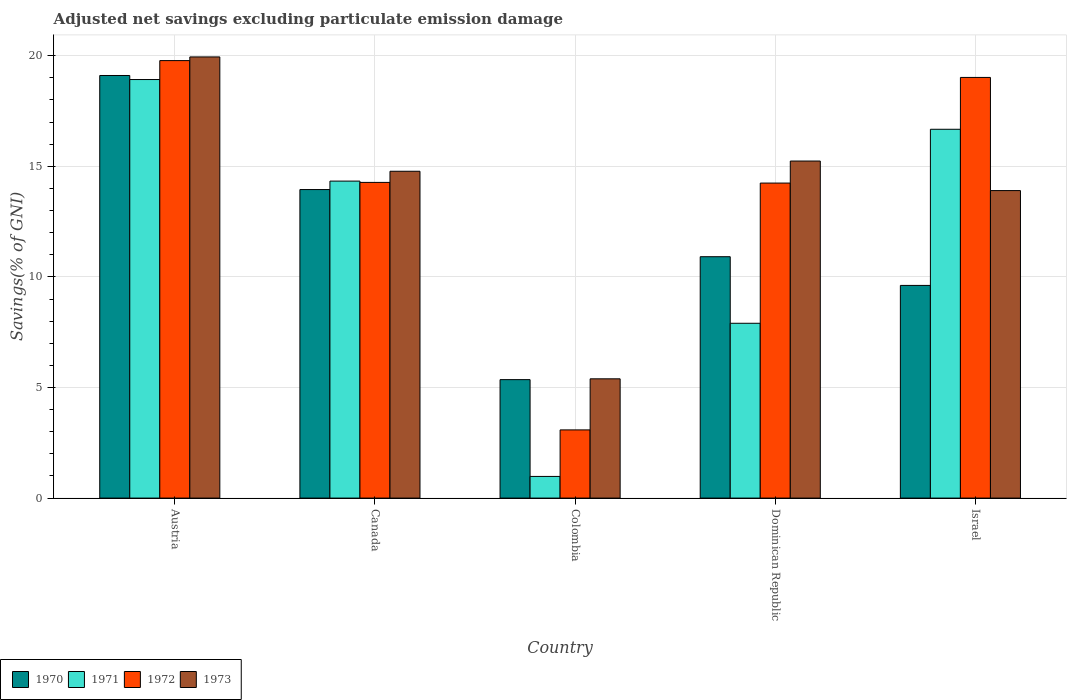How many different coloured bars are there?
Provide a succinct answer. 4. Are the number of bars per tick equal to the number of legend labels?
Provide a short and direct response. Yes. Are the number of bars on each tick of the X-axis equal?
Keep it short and to the point. Yes. How many bars are there on the 2nd tick from the left?
Your answer should be very brief. 4. How many bars are there on the 5th tick from the right?
Make the answer very short. 4. In how many cases, is the number of bars for a given country not equal to the number of legend labels?
Make the answer very short. 0. What is the adjusted net savings in 1973 in Israel?
Your answer should be compact. 13.9. Across all countries, what is the maximum adjusted net savings in 1971?
Your answer should be compact. 18.92. Across all countries, what is the minimum adjusted net savings in 1972?
Provide a succinct answer. 3.08. In which country was the adjusted net savings in 1972 maximum?
Give a very brief answer. Austria. What is the total adjusted net savings in 1972 in the graph?
Offer a very short reply. 70.39. What is the difference between the adjusted net savings in 1973 in Austria and that in Israel?
Your response must be concise. 6.04. What is the difference between the adjusted net savings in 1971 in Dominican Republic and the adjusted net savings in 1973 in Austria?
Provide a succinct answer. -12.04. What is the average adjusted net savings in 1973 per country?
Ensure brevity in your answer.  13.85. What is the difference between the adjusted net savings of/in 1972 and adjusted net savings of/in 1973 in Dominican Republic?
Ensure brevity in your answer.  -1. In how many countries, is the adjusted net savings in 1972 greater than 17 %?
Provide a succinct answer. 2. What is the ratio of the adjusted net savings in 1971 in Colombia to that in Israel?
Provide a succinct answer. 0.06. What is the difference between the highest and the second highest adjusted net savings in 1973?
Give a very brief answer. 5.17. What is the difference between the highest and the lowest adjusted net savings in 1970?
Offer a very short reply. 13.75. Is the sum of the adjusted net savings in 1972 in Canada and Israel greater than the maximum adjusted net savings in 1970 across all countries?
Keep it short and to the point. Yes. Is it the case that in every country, the sum of the adjusted net savings in 1970 and adjusted net savings in 1973 is greater than the sum of adjusted net savings in 1972 and adjusted net savings in 1971?
Offer a terse response. No. Is it the case that in every country, the sum of the adjusted net savings in 1973 and adjusted net savings in 1970 is greater than the adjusted net savings in 1971?
Offer a very short reply. Yes. Are the values on the major ticks of Y-axis written in scientific E-notation?
Provide a succinct answer. No. Does the graph contain any zero values?
Keep it short and to the point. No. Does the graph contain grids?
Offer a very short reply. Yes. Where does the legend appear in the graph?
Provide a succinct answer. Bottom left. What is the title of the graph?
Ensure brevity in your answer.  Adjusted net savings excluding particulate emission damage. Does "2007" appear as one of the legend labels in the graph?
Offer a terse response. No. What is the label or title of the Y-axis?
Ensure brevity in your answer.  Savings(% of GNI). What is the Savings(% of GNI) in 1970 in Austria?
Provide a short and direct response. 19.11. What is the Savings(% of GNI) in 1971 in Austria?
Your answer should be very brief. 18.92. What is the Savings(% of GNI) in 1972 in Austria?
Offer a terse response. 19.78. What is the Savings(% of GNI) in 1973 in Austria?
Keep it short and to the point. 19.94. What is the Savings(% of GNI) of 1970 in Canada?
Give a very brief answer. 13.95. What is the Savings(% of GNI) of 1971 in Canada?
Provide a succinct answer. 14.33. What is the Savings(% of GNI) of 1972 in Canada?
Give a very brief answer. 14.27. What is the Savings(% of GNI) in 1973 in Canada?
Ensure brevity in your answer.  14.78. What is the Savings(% of GNI) of 1970 in Colombia?
Your response must be concise. 5.36. What is the Savings(% of GNI) of 1971 in Colombia?
Ensure brevity in your answer.  0.98. What is the Savings(% of GNI) of 1972 in Colombia?
Your response must be concise. 3.08. What is the Savings(% of GNI) of 1973 in Colombia?
Keep it short and to the point. 5.39. What is the Savings(% of GNI) of 1970 in Dominican Republic?
Your response must be concise. 10.91. What is the Savings(% of GNI) in 1971 in Dominican Republic?
Provide a succinct answer. 7.9. What is the Savings(% of GNI) of 1972 in Dominican Republic?
Offer a very short reply. 14.24. What is the Savings(% of GNI) in 1973 in Dominican Republic?
Make the answer very short. 15.24. What is the Savings(% of GNI) of 1970 in Israel?
Your response must be concise. 9.61. What is the Savings(% of GNI) of 1971 in Israel?
Keep it short and to the point. 16.67. What is the Savings(% of GNI) in 1972 in Israel?
Your answer should be very brief. 19.02. What is the Savings(% of GNI) of 1973 in Israel?
Your answer should be compact. 13.9. Across all countries, what is the maximum Savings(% of GNI) in 1970?
Ensure brevity in your answer.  19.11. Across all countries, what is the maximum Savings(% of GNI) in 1971?
Offer a very short reply. 18.92. Across all countries, what is the maximum Savings(% of GNI) in 1972?
Keep it short and to the point. 19.78. Across all countries, what is the maximum Savings(% of GNI) of 1973?
Give a very brief answer. 19.94. Across all countries, what is the minimum Savings(% of GNI) of 1970?
Offer a very short reply. 5.36. Across all countries, what is the minimum Savings(% of GNI) in 1971?
Give a very brief answer. 0.98. Across all countries, what is the minimum Savings(% of GNI) in 1972?
Offer a terse response. 3.08. Across all countries, what is the minimum Savings(% of GNI) in 1973?
Ensure brevity in your answer.  5.39. What is the total Savings(% of GNI) of 1970 in the graph?
Your answer should be compact. 58.94. What is the total Savings(% of GNI) of 1971 in the graph?
Offer a very short reply. 58.81. What is the total Savings(% of GNI) in 1972 in the graph?
Provide a short and direct response. 70.39. What is the total Savings(% of GNI) in 1973 in the graph?
Make the answer very short. 69.25. What is the difference between the Savings(% of GNI) of 1970 in Austria and that in Canada?
Ensure brevity in your answer.  5.16. What is the difference between the Savings(% of GNI) of 1971 in Austria and that in Canada?
Provide a succinct answer. 4.59. What is the difference between the Savings(% of GNI) of 1972 in Austria and that in Canada?
Offer a very short reply. 5.51. What is the difference between the Savings(% of GNI) of 1973 in Austria and that in Canada?
Give a very brief answer. 5.17. What is the difference between the Savings(% of GNI) of 1970 in Austria and that in Colombia?
Provide a short and direct response. 13.75. What is the difference between the Savings(% of GNI) of 1971 in Austria and that in Colombia?
Offer a very short reply. 17.94. What is the difference between the Savings(% of GNI) in 1972 in Austria and that in Colombia?
Give a very brief answer. 16.7. What is the difference between the Savings(% of GNI) of 1973 in Austria and that in Colombia?
Offer a terse response. 14.55. What is the difference between the Savings(% of GNI) of 1970 in Austria and that in Dominican Republic?
Provide a short and direct response. 8.19. What is the difference between the Savings(% of GNI) in 1971 in Austria and that in Dominican Republic?
Your response must be concise. 11.02. What is the difference between the Savings(% of GNI) of 1972 in Austria and that in Dominican Republic?
Your response must be concise. 5.54. What is the difference between the Savings(% of GNI) of 1973 in Austria and that in Dominican Republic?
Offer a terse response. 4.71. What is the difference between the Savings(% of GNI) of 1970 in Austria and that in Israel?
Offer a very short reply. 9.49. What is the difference between the Savings(% of GNI) of 1971 in Austria and that in Israel?
Provide a short and direct response. 2.25. What is the difference between the Savings(% of GNI) in 1972 in Austria and that in Israel?
Provide a succinct answer. 0.76. What is the difference between the Savings(% of GNI) of 1973 in Austria and that in Israel?
Offer a very short reply. 6.04. What is the difference between the Savings(% of GNI) of 1970 in Canada and that in Colombia?
Offer a very short reply. 8.59. What is the difference between the Savings(% of GNI) of 1971 in Canada and that in Colombia?
Ensure brevity in your answer.  13.35. What is the difference between the Savings(% of GNI) of 1972 in Canada and that in Colombia?
Your response must be concise. 11.19. What is the difference between the Savings(% of GNI) in 1973 in Canada and that in Colombia?
Offer a very short reply. 9.38. What is the difference between the Savings(% of GNI) of 1970 in Canada and that in Dominican Republic?
Make the answer very short. 3.04. What is the difference between the Savings(% of GNI) of 1971 in Canada and that in Dominican Republic?
Ensure brevity in your answer.  6.43. What is the difference between the Savings(% of GNI) of 1972 in Canada and that in Dominican Republic?
Your response must be concise. 0.03. What is the difference between the Savings(% of GNI) of 1973 in Canada and that in Dominican Republic?
Offer a very short reply. -0.46. What is the difference between the Savings(% of GNI) in 1970 in Canada and that in Israel?
Ensure brevity in your answer.  4.33. What is the difference between the Savings(% of GNI) of 1971 in Canada and that in Israel?
Make the answer very short. -2.34. What is the difference between the Savings(% of GNI) of 1972 in Canada and that in Israel?
Make the answer very short. -4.75. What is the difference between the Savings(% of GNI) of 1973 in Canada and that in Israel?
Your answer should be compact. 0.87. What is the difference between the Savings(% of GNI) in 1970 in Colombia and that in Dominican Republic?
Make the answer very short. -5.56. What is the difference between the Savings(% of GNI) of 1971 in Colombia and that in Dominican Republic?
Offer a very short reply. -6.92. What is the difference between the Savings(% of GNI) in 1972 in Colombia and that in Dominican Republic?
Your answer should be compact. -11.16. What is the difference between the Savings(% of GNI) in 1973 in Colombia and that in Dominican Republic?
Offer a very short reply. -9.85. What is the difference between the Savings(% of GNI) of 1970 in Colombia and that in Israel?
Offer a terse response. -4.26. What is the difference between the Savings(% of GNI) in 1971 in Colombia and that in Israel?
Give a very brief answer. -15.7. What is the difference between the Savings(% of GNI) in 1972 in Colombia and that in Israel?
Keep it short and to the point. -15.94. What is the difference between the Savings(% of GNI) of 1973 in Colombia and that in Israel?
Your answer should be compact. -8.51. What is the difference between the Savings(% of GNI) in 1970 in Dominican Republic and that in Israel?
Provide a succinct answer. 1.3. What is the difference between the Savings(% of GNI) of 1971 in Dominican Republic and that in Israel?
Ensure brevity in your answer.  -8.77. What is the difference between the Savings(% of GNI) of 1972 in Dominican Republic and that in Israel?
Give a very brief answer. -4.78. What is the difference between the Savings(% of GNI) in 1973 in Dominican Republic and that in Israel?
Offer a very short reply. 1.34. What is the difference between the Savings(% of GNI) in 1970 in Austria and the Savings(% of GNI) in 1971 in Canada?
Keep it short and to the point. 4.77. What is the difference between the Savings(% of GNI) in 1970 in Austria and the Savings(% of GNI) in 1972 in Canada?
Your answer should be very brief. 4.83. What is the difference between the Savings(% of GNI) of 1970 in Austria and the Savings(% of GNI) of 1973 in Canada?
Your response must be concise. 4.33. What is the difference between the Savings(% of GNI) of 1971 in Austria and the Savings(% of GNI) of 1972 in Canada?
Offer a very short reply. 4.65. What is the difference between the Savings(% of GNI) of 1971 in Austria and the Savings(% of GNI) of 1973 in Canada?
Make the answer very short. 4.15. What is the difference between the Savings(% of GNI) in 1972 in Austria and the Savings(% of GNI) in 1973 in Canada?
Your answer should be compact. 5. What is the difference between the Savings(% of GNI) of 1970 in Austria and the Savings(% of GNI) of 1971 in Colombia?
Your answer should be very brief. 18.13. What is the difference between the Savings(% of GNI) of 1970 in Austria and the Savings(% of GNI) of 1972 in Colombia?
Provide a short and direct response. 16.02. What is the difference between the Savings(% of GNI) of 1970 in Austria and the Savings(% of GNI) of 1973 in Colombia?
Give a very brief answer. 13.71. What is the difference between the Savings(% of GNI) of 1971 in Austria and the Savings(% of GNI) of 1972 in Colombia?
Your answer should be compact. 15.84. What is the difference between the Savings(% of GNI) of 1971 in Austria and the Savings(% of GNI) of 1973 in Colombia?
Your answer should be very brief. 13.53. What is the difference between the Savings(% of GNI) of 1972 in Austria and the Savings(% of GNI) of 1973 in Colombia?
Your answer should be very brief. 14.39. What is the difference between the Savings(% of GNI) of 1970 in Austria and the Savings(% of GNI) of 1971 in Dominican Republic?
Provide a short and direct response. 11.2. What is the difference between the Savings(% of GNI) in 1970 in Austria and the Savings(% of GNI) in 1972 in Dominican Republic?
Make the answer very short. 4.86. What is the difference between the Savings(% of GNI) of 1970 in Austria and the Savings(% of GNI) of 1973 in Dominican Republic?
Offer a very short reply. 3.87. What is the difference between the Savings(% of GNI) in 1971 in Austria and the Savings(% of GNI) in 1972 in Dominican Republic?
Your response must be concise. 4.68. What is the difference between the Savings(% of GNI) in 1971 in Austria and the Savings(% of GNI) in 1973 in Dominican Republic?
Your answer should be very brief. 3.68. What is the difference between the Savings(% of GNI) in 1972 in Austria and the Savings(% of GNI) in 1973 in Dominican Republic?
Provide a succinct answer. 4.54. What is the difference between the Savings(% of GNI) in 1970 in Austria and the Savings(% of GNI) in 1971 in Israel?
Your response must be concise. 2.43. What is the difference between the Savings(% of GNI) in 1970 in Austria and the Savings(% of GNI) in 1972 in Israel?
Provide a succinct answer. 0.09. What is the difference between the Savings(% of GNI) in 1970 in Austria and the Savings(% of GNI) in 1973 in Israel?
Your answer should be very brief. 5.2. What is the difference between the Savings(% of GNI) in 1971 in Austria and the Savings(% of GNI) in 1972 in Israel?
Give a very brief answer. -0.1. What is the difference between the Savings(% of GNI) of 1971 in Austria and the Savings(% of GNI) of 1973 in Israel?
Your answer should be compact. 5.02. What is the difference between the Savings(% of GNI) in 1972 in Austria and the Savings(% of GNI) in 1973 in Israel?
Give a very brief answer. 5.88. What is the difference between the Savings(% of GNI) of 1970 in Canada and the Savings(% of GNI) of 1971 in Colombia?
Offer a very short reply. 12.97. What is the difference between the Savings(% of GNI) of 1970 in Canada and the Savings(% of GNI) of 1972 in Colombia?
Your answer should be very brief. 10.87. What is the difference between the Savings(% of GNI) in 1970 in Canada and the Savings(% of GNI) in 1973 in Colombia?
Provide a short and direct response. 8.56. What is the difference between the Savings(% of GNI) in 1971 in Canada and the Savings(% of GNI) in 1972 in Colombia?
Make the answer very short. 11.25. What is the difference between the Savings(% of GNI) in 1971 in Canada and the Savings(% of GNI) in 1973 in Colombia?
Your response must be concise. 8.94. What is the difference between the Savings(% of GNI) of 1972 in Canada and the Savings(% of GNI) of 1973 in Colombia?
Your response must be concise. 8.88. What is the difference between the Savings(% of GNI) of 1970 in Canada and the Savings(% of GNI) of 1971 in Dominican Republic?
Provide a short and direct response. 6.05. What is the difference between the Savings(% of GNI) in 1970 in Canada and the Savings(% of GNI) in 1972 in Dominican Republic?
Your response must be concise. -0.29. What is the difference between the Savings(% of GNI) in 1970 in Canada and the Savings(% of GNI) in 1973 in Dominican Republic?
Provide a succinct answer. -1.29. What is the difference between the Savings(% of GNI) of 1971 in Canada and the Savings(% of GNI) of 1972 in Dominican Republic?
Make the answer very short. 0.09. What is the difference between the Savings(% of GNI) of 1971 in Canada and the Savings(% of GNI) of 1973 in Dominican Republic?
Your answer should be compact. -0.91. What is the difference between the Savings(% of GNI) in 1972 in Canada and the Savings(% of GNI) in 1973 in Dominican Republic?
Provide a short and direct response. -0.97. What is the difference between the Savings(% of GNI) of 1970 in Canada and the Savings(% of GNI) of 1971 in Israel?
Offer a very short reply. -2.73. What is the difference between the Savings(% of GNI) of 1970 in Canada and the Savings(% of GNI) of 1972 in Israel?
Provide a short and direct response. -5.07. What is the difference between the Savings(% of GNI) in 1970 in Canada and the Savings(% of GNI) in 1973 in Israel?
Ensure brevity in your answer.  0.05. What is the difference between the Savings(% of GNI) in 1971 in Canada and the Savings(% of GNI) in 1972 in Israel?
Offer a terse response. -4.69. What is the difference between the Savings(% of GNI) of 1971 in Canada and the Savings(% of GNI) of 1973 in Israel?
Your answer should be compact. 0.43. What is the difference between the Savings(% of GNI) in 1972 in Canada and the Savings(% of GNI) in 1973 in Israel?
Your response must be concise. 0.37. What is the difference between the Savings(% of GNI) of 1970 in Colombia and the Savings(% of GNI) of 1971 in Dominican Republic?
Provide a short and direct response. -2.55. What is the difference between the Savings(% of GNI) in 1970 in Colombia and the Savings(% of GNI) in 1972 in Dominican Republic?
Your response must be concise. -8.89. What is the difference between the Savings(% of GNI) of 1970 in Colombia and the Savings(% of GNI) of 1973 in Dominican Republic?
Offer a terse response. -9.88. What is the difference between the Savings(% of GNI) of 1971 in Colombia and the Savings(% of GNI) of 1972 in Dominican Republic?
Provide a succinct answer. -13.26. What is the difference between the Savings(% of GNI) in 1971 in Colombia and the Savings(% of GNI) in 1973 in Dominican Republic?
Your answer should be compact. -14.26. What is the difference between the Savings(% of GNI) in 1972 in Colombia and the Savings(% of GNI) in 1973 in Dominican Republic?
Your answer should be compact. -12.15. What is the difference between the Savings(% of GNI) in 1970 in Colombia and the Savings(% of GNI) in 1971 in Israel?
Provide a succinct answer. -11.32. What is the difference between the Savings(% of GNI) of 1970 in Colombia and the Savings(% of GNI) of 1972 in Israel?
Provide a short and direct response. -13.66. What is the difference between the Savings(% of GNI) of 1970 in Colombia and the Savings(% of GNI) of 1973 in Israel?
Your response must be concise. -8.55. What is the difference between the Savings(% of GNI) of 1971 in Colombia and the Savings(% of GNI) of 1972 in Israel?
Provide a succinct answer. -18.04. What is the difference between the Savings(% of GNI) in 1971 in Colombia and the Savings(% of GNI) in 1973 in Israel?
Give a very brief answer. -12.92. What is the difference between the Savings(% of GNI) in 1972 in Colombia and the Savings(% of GNI) in 1973 in Israel?
Offer a terse response. -10.82. What is the difference between the Savings(% of GNI) in 1970 in Dominican Republic and the Savings(% of GNI) in 1971 in Israel?
Give a very brief answer. -5.76. What is the difference between the Savings(% of GNI) in 1970 in Dominican Republic and the Savings(% of GNI) in 1972 in Israel?
Give a very brief answer. -8.11. What is the difference between the Savings(% of GNI) in 1970 in Dominican Republic and the Savings(% of GNI) in 1973 in Israel?
Your answer should be very brief. -2.99. What is the difference between the Savings(% of GNI) of 1971 in Dominican Republic and the Savings(% of GNI) of 1972 in Israel?
Offer a very short reply. -11.11. What is the difference between the Savings(% of GNI) in 1971 in Dominican Republic and the Savings(% of GNI) in 1973 in Israel?
Provide a short and direct response. -6. What is the difference between the Savings(% of GNI) in 1972 in Dominican Republic and the Savings(% of GNI) in 1973 in Israel?
Ensure brevity in your answer.  0.34. What is the average Savings(% of GNI) of 1970 per country?
Make the answer very short. 11.79. What is the average Savings(% of GNI) in 1971 per country?
Give a very brief answer. 11.76. What is the average Savings(% of GNI) in 1972 per country?
Offer a terse response. 14.08. What is the average Savings(% of GNI) of 1973 per country?
Keep it short and to the point. 13.85. What is the difference between the Savings(% of GNI) in 1970 and Savings(% of GNI) in 1971 in Austria?
Your answer should be compact. 0.18. What is the difference between the Savings(% of GNI) of 1970 and Savings(% of GNI) of 1972 in Austria?
Offer a very short reply. -0.67. What is the difference between the Savings(% of GNI) of 1970 and Savings(% of GNI) of 1973 in Austria?
Offer a terse response. -0.84. What is the difference between the Savings(% of GNI) of 1971 and Savings(% of GNI) of 1972 in Austria?
Keep it short and to the point. -0.86. What is the difference between the Savings(% of GNI) in 1971 and Savings(% of GNI) in 1973 in Austria?
Ensure brevity in your answer.  -1.02. What is the difference between the Savings(% of GNI) in 1972 and Savings(% of GNI) in 1973 in Austria?
Give a very brief answer. -0.17. What is the difference between the Savings(% of GNI) in 1970 and Savings(% of GNI) in 1971 in Canada?
Ensure brevity in your answer.  -0.38. What is the difference between the Savings(% of GNI) in 1970 and Savings(% of GNI) in 1972 in Canada?
Your response must be concise. -0.32. What is the difference between the Savings(% of GNI) of 1970 and Savings(% of GNI) of 1973 in Canada?
Offer a very short reply. -0.83. What is the difference between the Savings(% of GNI) in 1971 and Savings(% of GNI) in 1972 in Canada?
Offer a terse response. 0.06. What is the difference between the Savings(% of GNI) of 1971 and Savings(% of GNI) of 1973 in Canada?
Make the answer very short. -0.45. What is the difference between the Savings(% of GNI) of 1972 and Savings(% of GNI) of 1973 in Canada?
Your answer should be compact. -0.5. What is the difference between the Savings(% of GNI) in 1970 and Savings(% of GNI) in 1971 in Colombia?
Give a very brief answer. 4.38. What is the difference between the Savings(% of GNI) in 1970 and Savings(% of GNI) in 1972 in Colombia?
Offer a very short reply. 2.27. What is the difference between the Savings(% of GNI) in 1970 and Savings(% of GNI) in 1973 in Colombia?
Your answer should be compact. -0.04. What is the difference between the Savings(% of GNI) in 1971 and Savings(% of GNI) in 1972 in Colombia?
Make the answer very short. -2.1. What is the difference between the Savings(% of GNI) of 1971 and Savings(% of GNI) of 1973 in Colombia?
Keep it short and to the point. -4.41. What is the difference between the Savings(% of GNI) in 1972 and Savings(% of GNI) in 1973 in Colombia?
Provide a short and direct response. -2.31. What is the difference between the Savings(% of GNI) of 1970 and Savings(% of GNI) of 1971 in Dominican Republic?
Provide a short and direct response. 3.01. What is the difference between the Savings(% of GNI) in 1970 and Savings(% of GNI) in 1972 in Dominican Republic?
Provide a short and direct response. -3.33. What is the difference between the Savings(% of GNI) of 1970 and Savings(% of GNI) of 1973 in Dominican Republic?
Make the answer very short. -4.33. What is the difference between the Savings(% of GNI) in 1971 and Savings(% of GNI) in 1972 in Dominican Republic?
Keep it short and to the point. -6.34. What is the difference between the Savings(% of GNI) in 1971 and Savings(% of GNI) in 1973 in Dominican Republic?
Offer a very short reply. -7.33. What is the difference between the Savings(% of GNI) of 1972 and Savings(% of GNI) of 1973 in Dominican Republic?
Your answer should be very brief. -1. What is the difference between the Savings(% of GNI) in 1970 and Savings(% of GNI) in 1971 in Israel?
Give a very brief answer. -7.06. What is the difference between the Savings(% of GNI) of 1970 and Savings(% of GNI) of 1972 in Israel?
Your answer should be very brief. -9.4. What is the difference between the Savings(% of GNI) in 1970 and Savings(% of GNI) in 1973 in Israel?
Keep it short and to the point. -4.29. What is the difference between the Savings(% of GNI) of 1971 and Savings(% of GNI) of 1972 in Israel?
Make the answer very short. -2.34. What is the difference between the Savings(% of GNI) in 1971 and Savings(% of GNI) in 1973 in Israel?
Your answer should be compact. 2.77. What is the difference between the Savings(% of GNI) in 1972 and Savings(% of GNI) in 1973 in Israel?
Give a very brief answer. 5.12. What is the ratio of the Savings(% of GNI) in 1970 in Austria to that in Canada?
Offer a terse response. 1.37. What is the ratio of the Savings(% of GNI) of 1971 in Austria to that in Canada?
Your answer should be very brief. 1.32. What is the ratio of the Savings(% of GNI) in 1972 in Austria to that in Canada?
Your response must be concise. 1.39. What is the ratio of the Savings(% of GNI) of 1973 in Austria to that in Canada?
Offer a very short reply. 1.35. What is the ratio of the Savings(% of GNI) in 1970 in Austria to that in Colombia?
Offer a very short reply. 3.57. What is the ratio of the Savings(% of GNI) in 1971 in Austria to that in Colombia?
Keep it short and to the point. 19.32. What is the ratio of the Savings(% of GNI) of 1972 in Austria to that in Colombia?
Ensure brevity in your answer.  6.42. What is the ratio of the Savings(% of GNI) in 1973 in Austria to that in Colombia?
Keep it short and to the point. 3.7. What is the ratio of the Savings(% of GNI) in 1970 in Austria to that in Dominican Republic?
Your response must be concise. 1.75. What is the ratio of the Savings(% of GNI) of 1971 in Austria to that in Dominican Republic?
Offer a very short reply. 2.39. What is the ratio of the Savings(% of GNI) of 1972 in Austria to that in Dominican Republic?
Ensure brevity in your answer.  1.39. What is the ratio of the Savings(% of GNI) of 1973 in Austria to that in Dominican Republic?
Offer a very short reply. 1.31. What is the ratio of the Savings(% of GNI) in 1970 in Austria to that in Israel?
Your answer should be compact. 1.99. What is the ratio of the Savings(% of GNI) in 1971 in Austria to that in Israel?
Ensure brevity in your answer.  1.13. What is the ratio of the Savings(% of GNI) of 1973 in Austria to that in Israel?
Offer a terse response. 1.43. What is the ratio of the Savings(% of GNI) of 1970 in Canada to that in Colombia?
Provide a succinct answer. 2.6. What is the ratio of the Savings(% of GNI) of 1971 in Canada to that in Colombia?
Provide a short and direct response. 14.64. What is the ratio of the Savings(% of GNI) in 1972 in Canada to that in Colombia?
Make the answer very short. 4.63. What is the ratio of the Savings(% of GNI) in 1973 in Canada to that in Colombia?
Keep it short and to the point. 2.74. What is the ratio of the Savings(% of GNI) in 1970 in Canada to that in Dominican Republic?
Your answer should be very brief. 1.28. What is the ratio of the Savings(% of GNI) of 1971 in Canada to that in Dominican Republic?
Your answer should be very brief. 1.81. What is the ratio of the Savings(% of GNI) of 1973 in Canada to that in Dominican Republic?
Ensure brevity in your answer.  0.97. What is the ratio of the Savings(% of GNI) of 1970 in Canada to that in Israel?
Offer a very short reply. 1.45. What is the ratio of the Savings(% of GNI) of 1971 in Canada to that in Israel?
Your answer should be compact. 0.86. What is the ratio of the Savings(% of GNI) of 1972 in Canada to that in Israel?
Offer a terse response. 0.75. What is the ratio of the Savings(% of GNI) in 1973 in Canada to that in Israel?
Your answer should be very brief. 1.06. What is the ratio of the Savings(% of GNI) of 1970 in Colombia to that in Dominican Republic?
Your answer should be compact. 0.49. What is the ratio of the Savings(% of GNI) of 1971 in Colombia to that in Dominican Republic?
Offer a terse response. 0.12. What is the ratio of the Savings(% of GNI) in 1972 in Colombia to that in Dominican Republic?
Your answer should be compact. 0.22. What is the ratio of the Savings(% of GNI) of 1973 in Colombia to that in Dominican Republic?
Provide a succinct answer. 0.35. What is the ratio of the Savings(% of GNI) of 1970 in Colombia to that in Israel?
Give a very brief answer. 0.56. What is the ratio of the Savings(% of GNI) in 1971 in Colombia to that in Israel?
Your response must be concise. 0.06. What is the ratio of the Savings(% of GNI) of 1972 in Colombia to that in Israel?
Provide a short and direct response. 0.16. What is the ratio of the Savings(% of GNI) in 1973 in Colombia to that in Israel?
Ensure brevity in your answer.  0.39. What is the ratio of the Savings(% of GNI) of 1970 in Dominican Republic to that in Israel?
Provide a short and direct response. 1.14. What is the ratio of the Savings(% of GNI) in 1971 in Dominican Republic to that in Israel?
Ensure brevity in your answer.  0.47. What is the ratio of the Savings(% of GNI) of 1972 in Dominican Republic to that in Israel?
Your answer should be compact. 0.75. What is the ratio of the Savings(% of GNI) in 1973 in Dominican Republic to that in Israel?
Ensure brevity in your answer.  1.1. What is the difference between the highest and the second highest Savings(% of GNI) in 1970?
Offer a terse response. 5.16. What is the difference between the highest and the second highest Savings(% of GNI) of 1971?
Provide a short and direct response. 2.25. What is the difference between the highest and the second highest Savings(% of GNI) of 1972?
Provide a succinct answer. 0.76. What is the difference between the highest and the second highest Savings(% of GNI) of 1973?
Keep it short and to the point. 4.71. What is the difference between the highest and the lowest Savings(% of GNI) of 1970?
Make the answer very short. 13.75. What is the difference between the highest and the lowest Savings(% of GNI) of 1971?
Make the answer very short. 17.94. What is the difference between the highest and the lowest Savings(% of GNI) in 1972?
Ensure brevity in your answer.  16.7. What is the difference between the highest and the lowest Savings(% of GNI) of 1973?
Your response must be concise. 14.55. 